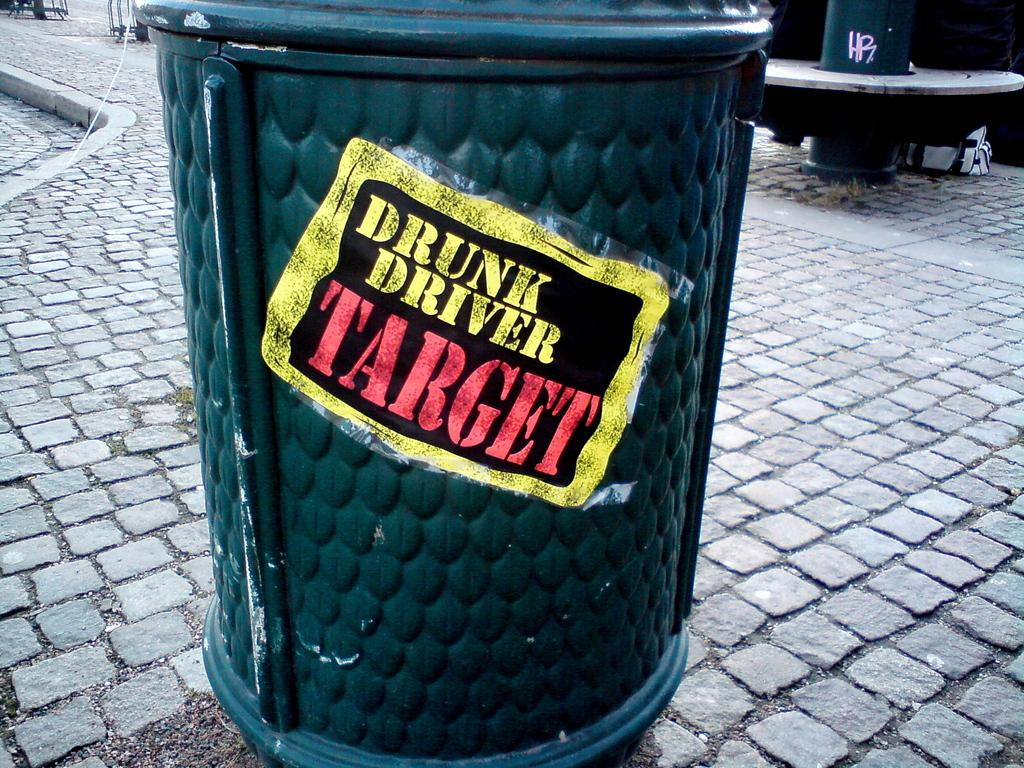<image>
Summarize the visual content of the image. A garbage receptacle has a sticker on it which reads "Drunk Driver Target." 